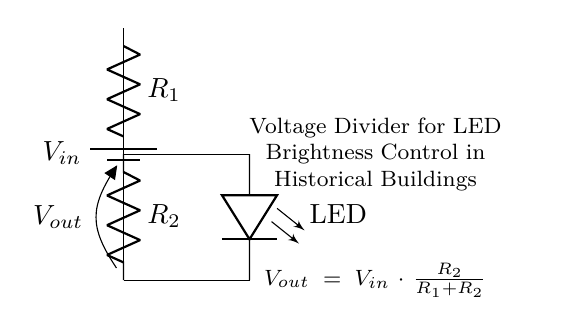What is the power source in the circuit? The power source is represented by the battery symbol at the top of the diagram. It provides the input voltage, denoted as V_in.
Answer: battery What is R_1's role in the circuit? R_1 acts as one of the resistors in the voltage divider network, affecting the total resistance and thus the output voltage.
Answer: voltage division What is the output voltage formula? The output voltage, V_out, is calculated using the formula shown in the diagram: V_out = V_in * (R_2 / (R_1 + R_2)).
Answer: V_out = V_in * (R_2 / (R_1 + R_2)) How many resistors are present in this circuit? The circuit includes two resistors, R_1 and R_2, positioned in series.
Answer: two What will happen to the LED if R_2 is increased? Increasing R_2 will result in a higher V_out, which increases the current through the LED, making it brighter.
Answer: brighter What is the function of R_2 in this voltage divider? R_2 is responsible for defining the output voltage in conjunction with R_1, allowing control of the LED brightness based on its value.
Answer: output control 